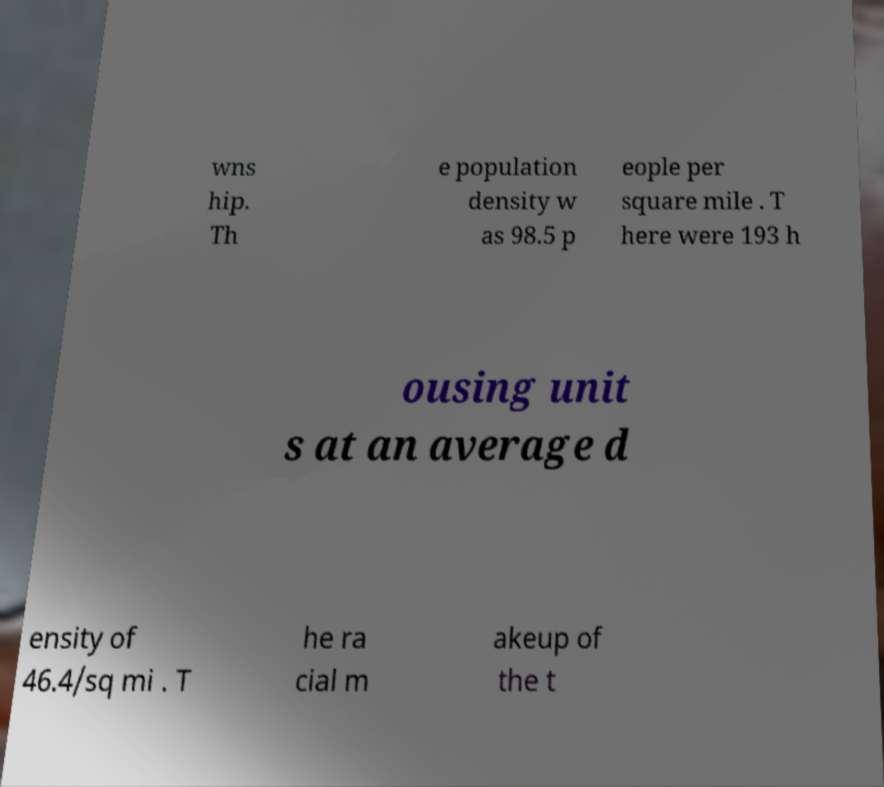There's text embedded in this image that I need extracted. Can you transcribe it verbatim? wns hip. Th e population density w as 98.5 p eople per square mile . T here were 193 h ousing unit s at an average d ensity of 46.4/sq mi . T he ra cial m akeup of the t 